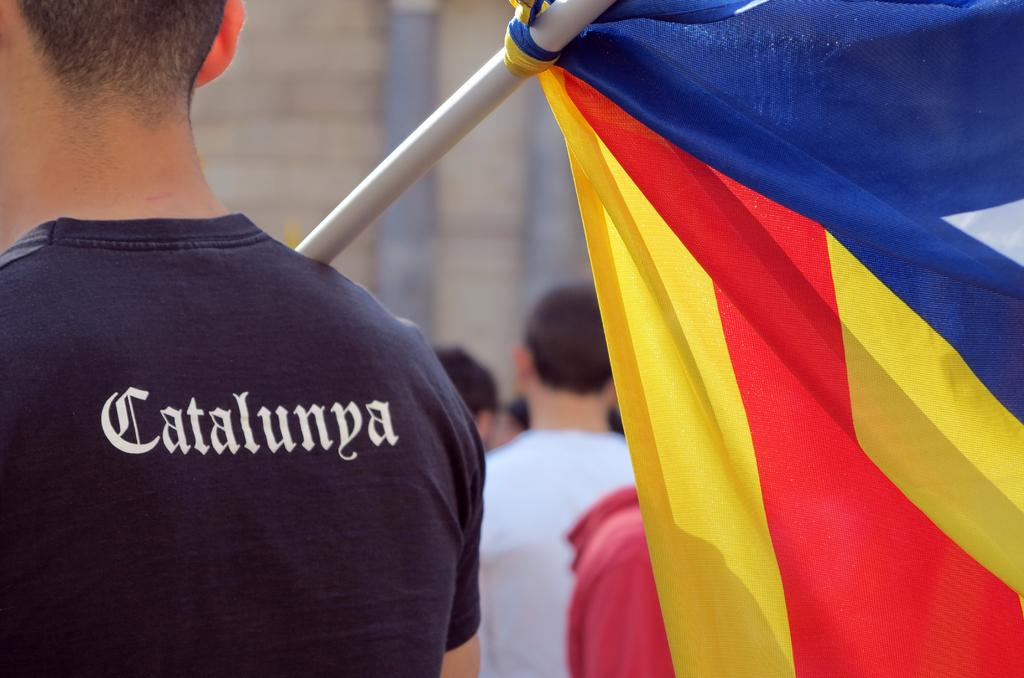What is the main subject in the center of the image? There is a person carrying a flag in the center of the image. What can be seen in the background of the image? There is a building in the background of the image. What architectural features are present in the image? There are pillars in the image. Are there any other people in the image besides the person carrying the flag? Yes, there are people in the image. What type of meal is being prepared by the boys in the image? There are no boys or meal preparation present in the image. 